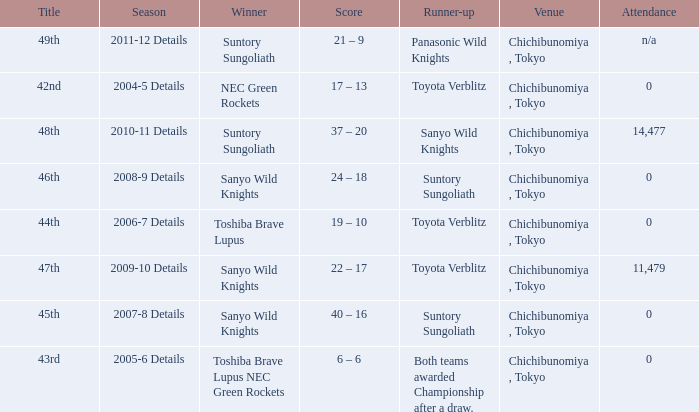What is the Title when the winner was suntory sungoliath, and a Season of 2011-12 details? 49th. 